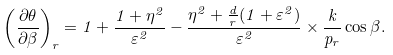Convert formula to latex. <formula><loc_0><loc_0><loc_500><loc_500>\left ( \frac { \partial { \theta } } { \partial \beta } \right ) _ { r } = 1 + \frac { 1 + \eta ^ { 2 } } { \varepsilon ^ { 2 } } - \frac { \eta ^ { 2 } + \frac { d } { r } ( 1 + \varepsilon ^ { 2 } ) } { \varepsilon ^ { 2 } } \times \frac { k } { p _ { r } } \cos \beta .</formula> 